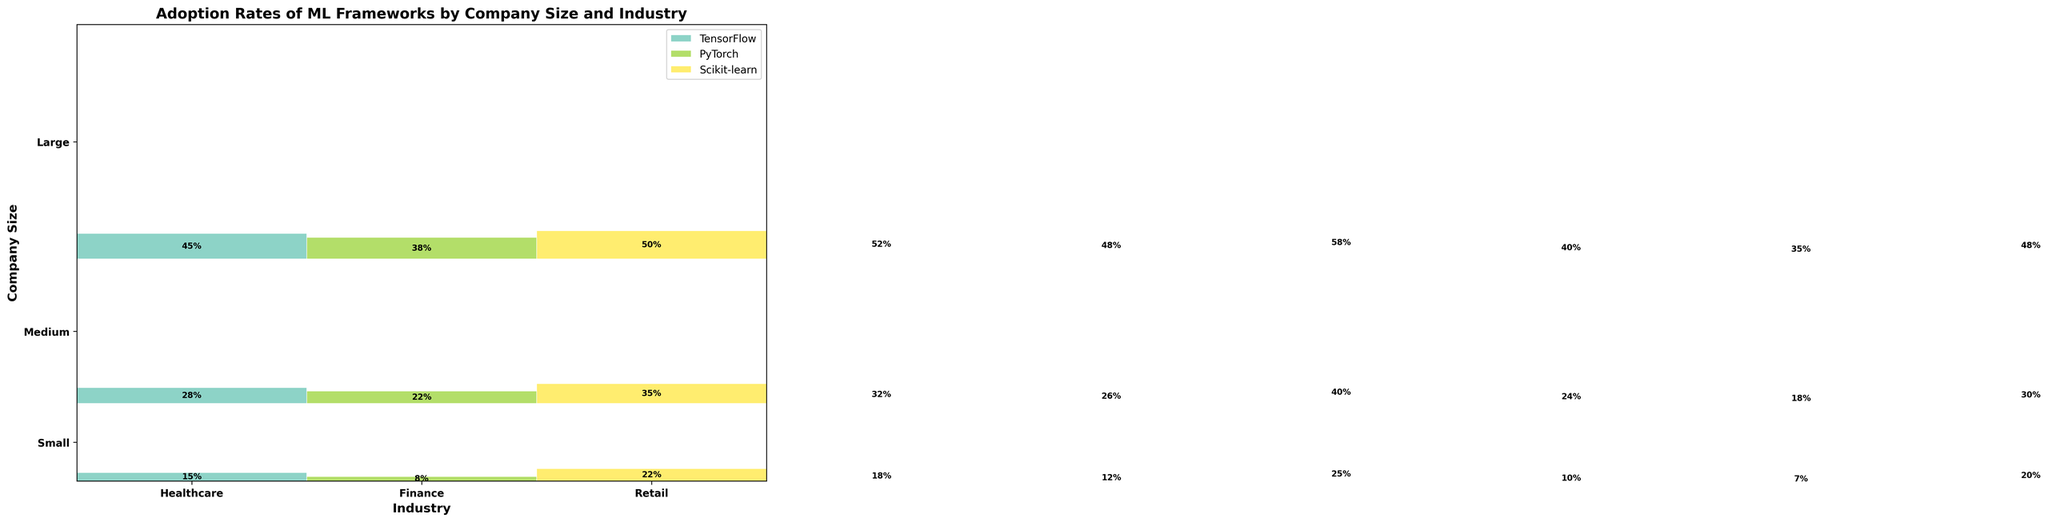What industries are represented in the plot? The x-axis labels indicate the industries represented in the plot. These are displayed as textual labels below each section of the plot. Therefore, based on the figure, the industries are Healthcare, Finance, and Retail.
Answer: Healthcare, Finance, Retail What is the highest adoption rate for Scikit-learn in the Large company size category? To find the highest adoption rate for Scikit-learn in the Large company size category, identify the rectangle representing Scikit-learn usage in the Large company size row and look at the textual label inside the block. The largest numeric value visible is 58%.
Answer: 58% Which framework shows the least adoption rate in Medium-sized Retail companies? Locate the Medium company size section and the Retail industry on the x-axis. Compare the relative sizes of the rectangles colored for each framework within this section. The smallest rectangle, corresponded with its label, indicates that PyTorch has the smallest adoption rate.
Answer: PyTorch What is the sum of the adoption rates of all frameworks for Small Finance companies? Add the adoption rates for all frameworks in the Small Finance category. These values are 18% (TensorFlow), 12% (PyTorch), and 25% (Scikit-learn). Summing these gives 18 + 12 + 25 = 55%.
Answer: 55% Do Large Healthcare companies prefer PyTorch or TensorFlow more? In the Large company size and Healthcare industry section, compare the sizes and labels of the rectangles for PyTorch and TensorFlow. The textual labels show PyTorch at 38% and TensorFlow at 45%. TensorFlow has a higher value; therefore, it is preferred more.
Answer: TensorFlow Among Medium-sized companies, which industry has the highest adoption rate for TensorFlow? In the Medium company size section, compare the sizes and labels of the rectangles corresponding to TensorFlow for each industry. Healthcare, Finance, and Retail have adoption rates of 28%, 32%, and 24%, respectively. Therefore, Finance has the highest adoption rate.
Answer: Finance Are adoption rates for Scikit-learn higher on average in Large companies compared to Small companies? Calculate the average adoption rate for Scikit-learn in Large and Small companies. Large companies have adoption rates of 50% (Healthcare), 58% (Finance), and 48% (Retail). The average is (50 + 58 + 48) / 3 = 52%. Small companies have rates of 22% (Healthcare), 25% (Finance), and 20% (Retail). The average is (22 + 25 + 20) / 3 = 22.33%. Comparing these averages, Large companies have higher adoption rates.
Answer: Yes Which company size has the highest total adoption rate across all frameworks and industries? Calculate the sum of adoption rates for each company size by summing up all individual rates in each category: 
- Small companies: 15 + 8 + 22 + 18 + 12 + 25 + 10 + 7 + 20 = 137
- Medium companies: 28 + 22 + 35 + 32 + 26 + 40 + 24 + 18 + 30 = 255
- Large companies: 45 + 38 + 50 + 52 + 48 + 58 + 40 + 35 + 48 = 414
Seeing the sums, Large companies have the highest total adoption rate.
Answer: Large Which framework tends to have the highest adoption rate across different company sizes? Compare the average adoption rates per framework across all company sizes. Sum and average adoption rates per framework:
- TensorFlow: (15+18+10+28+32+24+45+52+40)/9
- PyTorch: (8+12+7+22+26+18+38+48+35)/9
- Scikit-learn: (22+25+20+35+40+30+50+58+48)/9
The calculated averages indicate that Scikit-learn consistently has the highest adoption rate across different sizes.
Answer: Scikit-learn 